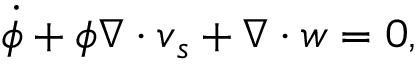Convert formula to latex. <formula><loc_0><loc_0><loc_500><loc_500>\dot { \phi } + \phi \nabla \cdot v _ { s } + \nabla \cdot w = 0 ,</formula> 